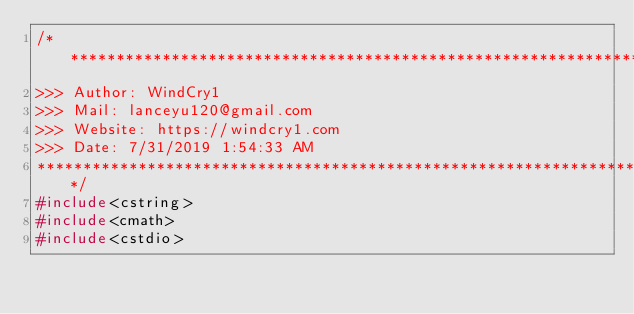Convert code to text. <code><loc_0><loc_0><loc_500><loc_500><_C++_>/*************************************************************************
>>> Author: WindCry1
>>> Mail: lanceyu120@gmail.com
>>> Website: https://windcry1.com
>>> Date: 7/31/2019 1:54:33 AM
*************************************************************************/
#include<cstring>
#include<cmath>
#include<cstdio></code> 